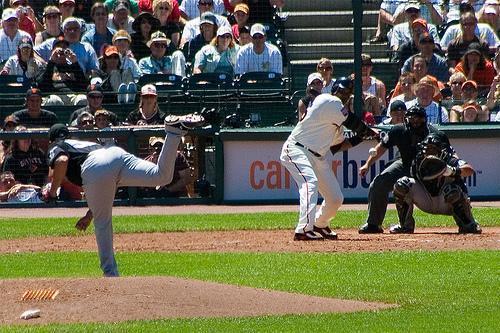What is the sponsor's industry?
Indicate the correct response by choosing from the four available options to answer the question.
Options: Automotive, job search, electronics, clothing. Job search. 